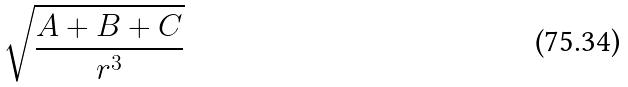Convert formula to latex. <formula><loc_0><loc_0><loc_500><loc_500>\sqrt { \frac { A + B + C } { r ^ { 3 } } }</formula> 